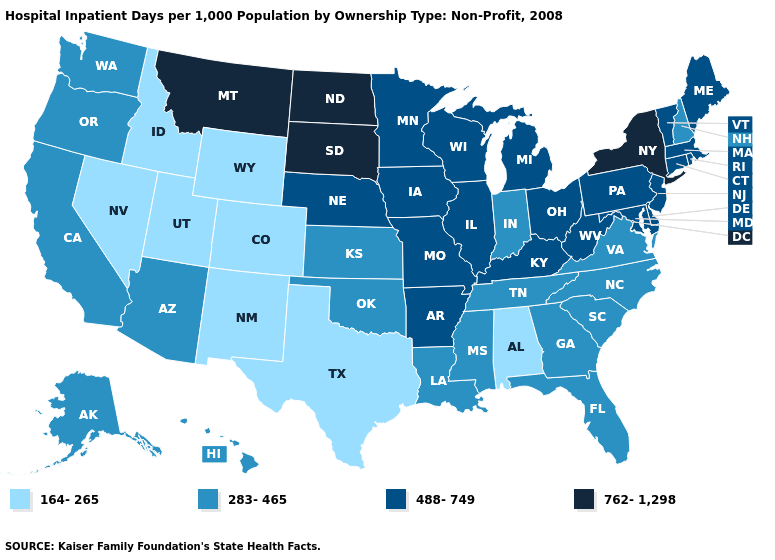Which states have the lowest value in the USA?
Write a very short answer. Alabama, Colorado, Idaho, Nevada, New Mexico, Texas, Utah, Wyoming. What is the value of Oklahoma?
Give a very brief answer. 283-465. Does Delaware have the highest value in the South?
Give a very brief answer. Yes. What is the value of Colorado?
Give a very brief answer. 164-265. Name the states that have a value in the range 762-1,298?
Keep it brief. Montana, New York, North Dakota, South Dakota. What is the value of Delaware?
Answer briefly. 488-749. What is the value of Mississippi?
Short answer required. 283-465. Does the map have missing data?
Write a very short answer. No. Among the states that border California , which have the lowest value?
Be succinct. Nevada. What is the value of North Dakota?
Answer briefly. 762-1,298. Name the states that have a value in the range 488-749?
Keep it brief. Arkansas, Connecticut, Delaware, Illinois, Iowa, Kentucky, Maine, Maryland, Massachusetts, Michigan, Minnesota, Missouri, Nebraska, New Jersey, Ohio, Pennsylvania, Rhode Island, Vermont, West Virginia, Wisconsin. Name the states that have a value in the range 164-265?
Answer briefly. Alabama, Colorado, Idaho, Nevada, New Mexico, Texas, Utah, Wyoming. How many symbols are there in the legend?
Short answer required. 4. Name the states that have a value in the range 283-465?
Keep it brief. Alaska, Arizona, California, Florida, Georgia, Hawaii, Indiana, Kansas, Louisiana, Mississippi, New Hampshire, North Carolina, Oklahoma, Oregon, South Carolina, Tennessee, Virginia, Washington. Does Wyoming have a higher value than Missouri?
Be succinct. No. 